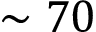Convert formula to latex. <formula><loc_0><loc_0><loc_500><loc_500>\sim 7 0</formula> 